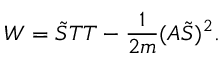Convert formula to latex. <formula><loc_0><loc_0><loc_500><loc_500>W = \tilde { S } T T - \frac { 1 } { 2 m } ( A \tilde { S } ) ^ { 2 } .</formula> 